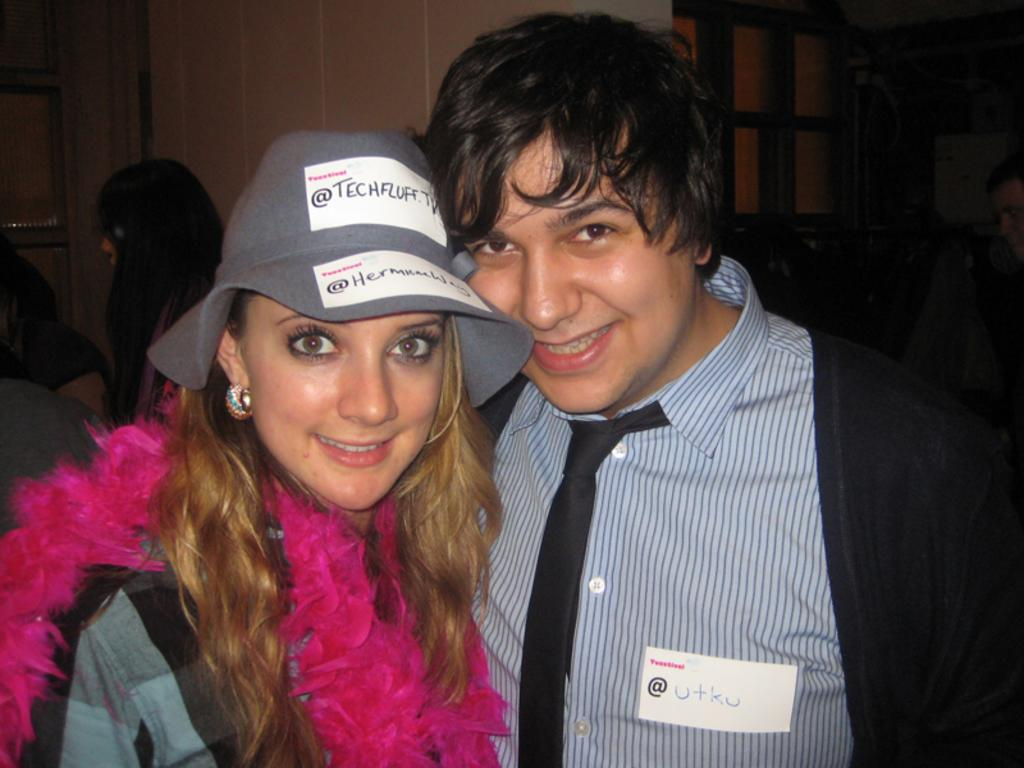How many people are present in the image? There are two people, a man and a woman, present in the image. What is the woman wearing on her head? The woman is wearing a cap. What can be seen in the background of the image? There is a wall in the background of the image. Can you describe the person on the left side of the image? There is another person on the left side of the image. What type of bubble can be seen floating near the man in the image? There is no bubble present in the image. What scientific system is being demonstrated by the people in the image? There is no scientific system being demonstrated in the image; it simply shows two people and a woman wearing a cap. 